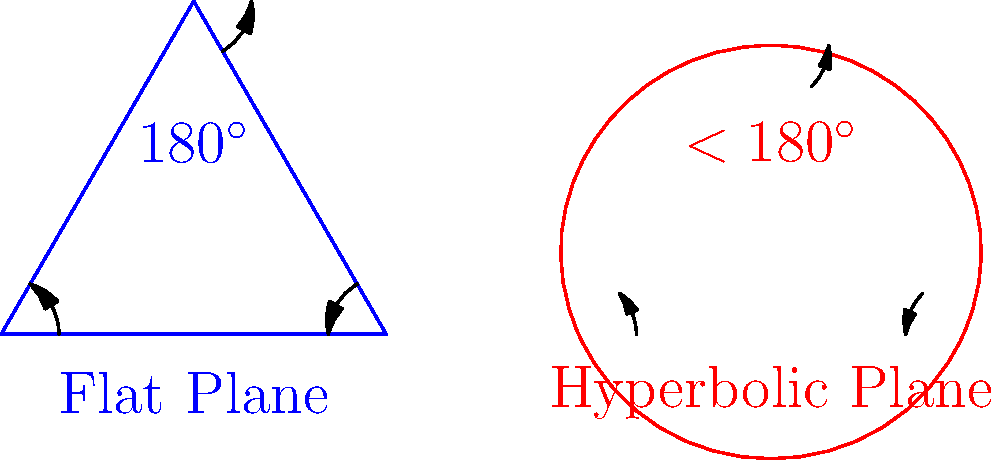In your latest podcast episode about the mathematical concepts in classic radio dramas, you're discussing the differences between Euclidean and non-Euclidean geometry. How would you explain to your listeners the key distinction between the sum of angles in a triangle on a flat (Euclidean) plane versus a hyperbolic (non-Euclidean) plane, as illustrated in the diagram? To explain this concept to podcast listeners, we can break it down into steps:

1. Euclidean (Flat) Plane:
   - In classic geometry, taught in most schools, we work with flat planes.
   - On a flat plane, the sum of angles in any triangle is always 180°.
   - This is a fundamental rule in Euclidean geometry.

2. Hyperbolic (Non-Euclidean) Plane:
   - Hyperbolic geometry is a type of non-Euclidean geometry.
   - On a hyperbolic plane, space is curved in a way that's hard to visualize in our 3D world.
   - In this curved space, the sum of angles in a triangle is always less than 180°.

3. Key Differences:
   - Flat plane: $\text{Angle Sum} = 180^\circ$
   - Hyperbolic plane: $\text{Angle Sum} < 180^\circ$

4. Implications:
   - This difference affects many geometric properties and calculations.
   - It challenges our intuitive understanding of space and shapes.

5. Real-world Relevance:
   - While Euclidean geometry works well for everyday life, non-Euclidean geometry is crucial in understanding the structure of the universe on a large scale.
   - Einstein's theory of general relativity uses non-Euclidean geometry to describe the curvature of spacetime.

6. Connection to Radio Dramas:
   - Some science fiction radio dramas might explore concepts of curved space or alternate dimensions, which could be related to non-Euclidean geometry.
   - Understanding these geometric principles can enrich the listening experience and appreciation of such storylines.
Answer: In a flat plane, triangle angles sum to 180°; in a hyperbolic plane, they sum to less than 180°. 